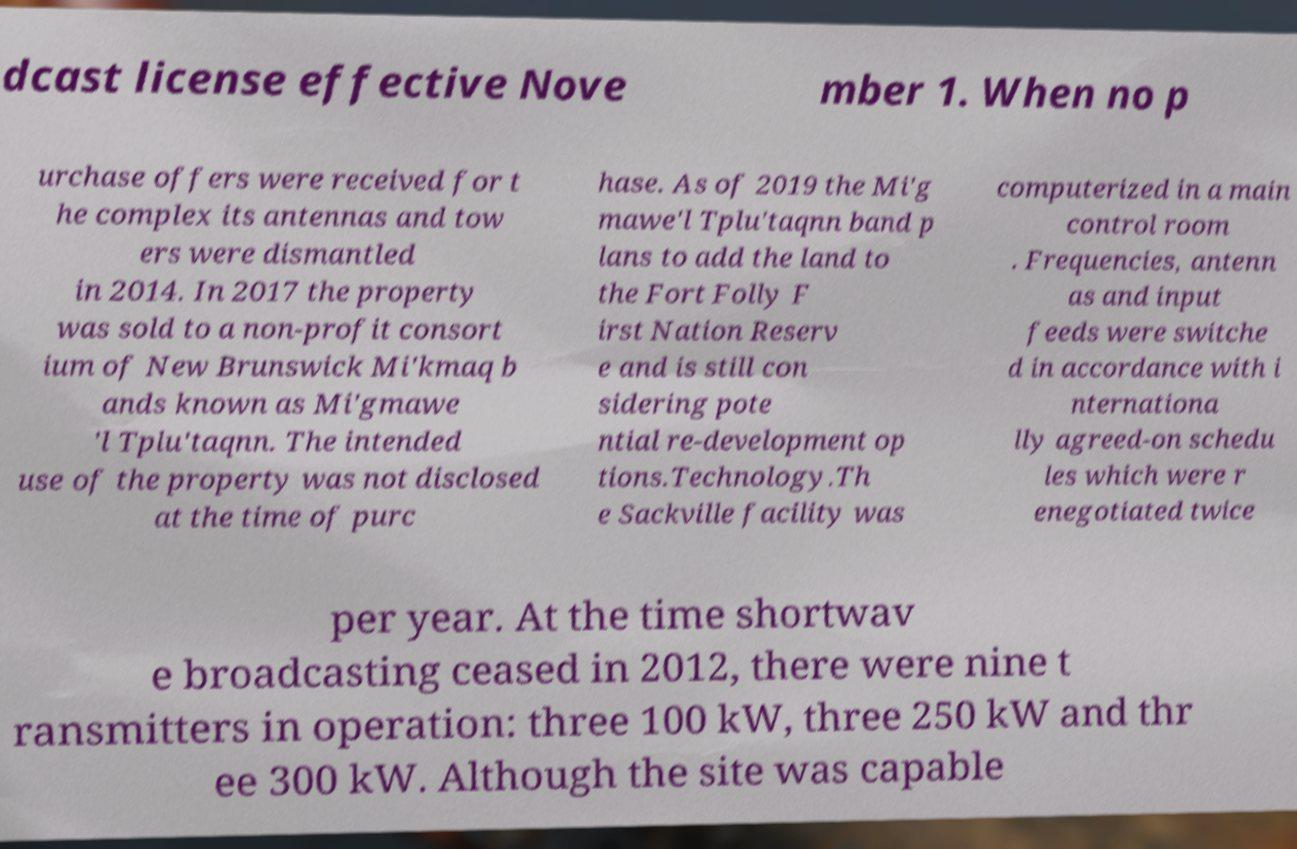Please read and relay the text visible in this image. What does it say? dcast license effective Nove mber 1. When no p urchase offers were received for t he complex its antennas and tow ers were dismantled in 2014. In 2017 the property was sold to a non-profit consort ium of New Brunswick Mi'kmaq b ands known as Mi'gmawe 'l Tplu'taqnn. The intended use of the property was not disclosed at the time of purc hase. As of 2019 the Mi'g mawe'l Tplu'taqnn band p lans to add the land to the Fort Folly F irst Nation Reserv e and is still con sidering pote ntial re-development op tions.Technology.Th e Sackville facility was computerized in a main control room . Frequencies, antenn as and input feeds were switche d in accordance with i nternationa lly agreed-on schedu les which were r enegotiated twice per year. At the time shortwav e broadcasting ceased in 2012, there were nine t ransmitters in operation: three 100 kW, three 250 kW and thr ee 300 kW. Although the site was capable 